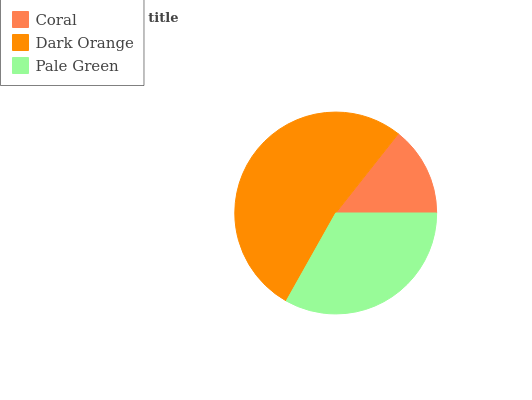Is Coral the minimum?
Answer yes or no. Yes. Is Dark Orange the maximum?
Answer yes or no. Yes. Is Pale Green the minimum?
Answer yes or no. No. Is Pale Green the maximum?
Answer yes or no. No. Is Dark Orange greater than Pale Green?
Answer yes or no. Yes. Is Pale Green less than Dark Orange?
Answer yes or no. Yes. Is Pale Green greater than Dark Orange?
Answer yes or no. No. Is Dark Orange less than Pale Green?
Answer yes or no. No. Is Pale Green the high median?
Answer yes or no. Yes. Is Pale Green the low median?
Answer yes or no. Yes. Is Coral the high median?
Answer yes or no. No. Is Dark Orange the low median?
Answer yes or no. No. 